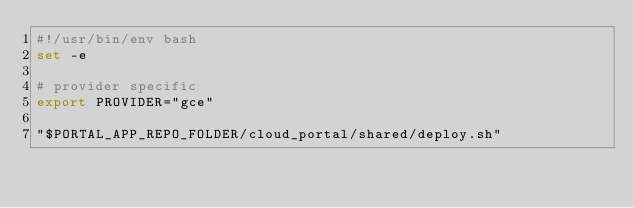Convert code to text. <code><loc_0><loc_0><loc_500><loc_500><_Bash_>#!/usr/bin/env bash
set -e

# provider specific
export PROVIDER="gce"

"$PORTAL_APP_REPO_FOLDER/cloud_portal/shared/deploy.sh"
</code> 